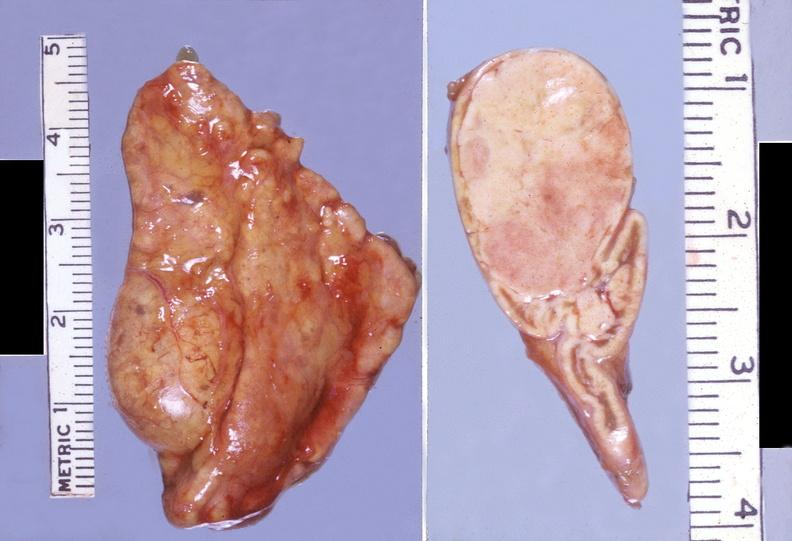s endocrine present?
Answer the question using a single word or phrase. Yes 